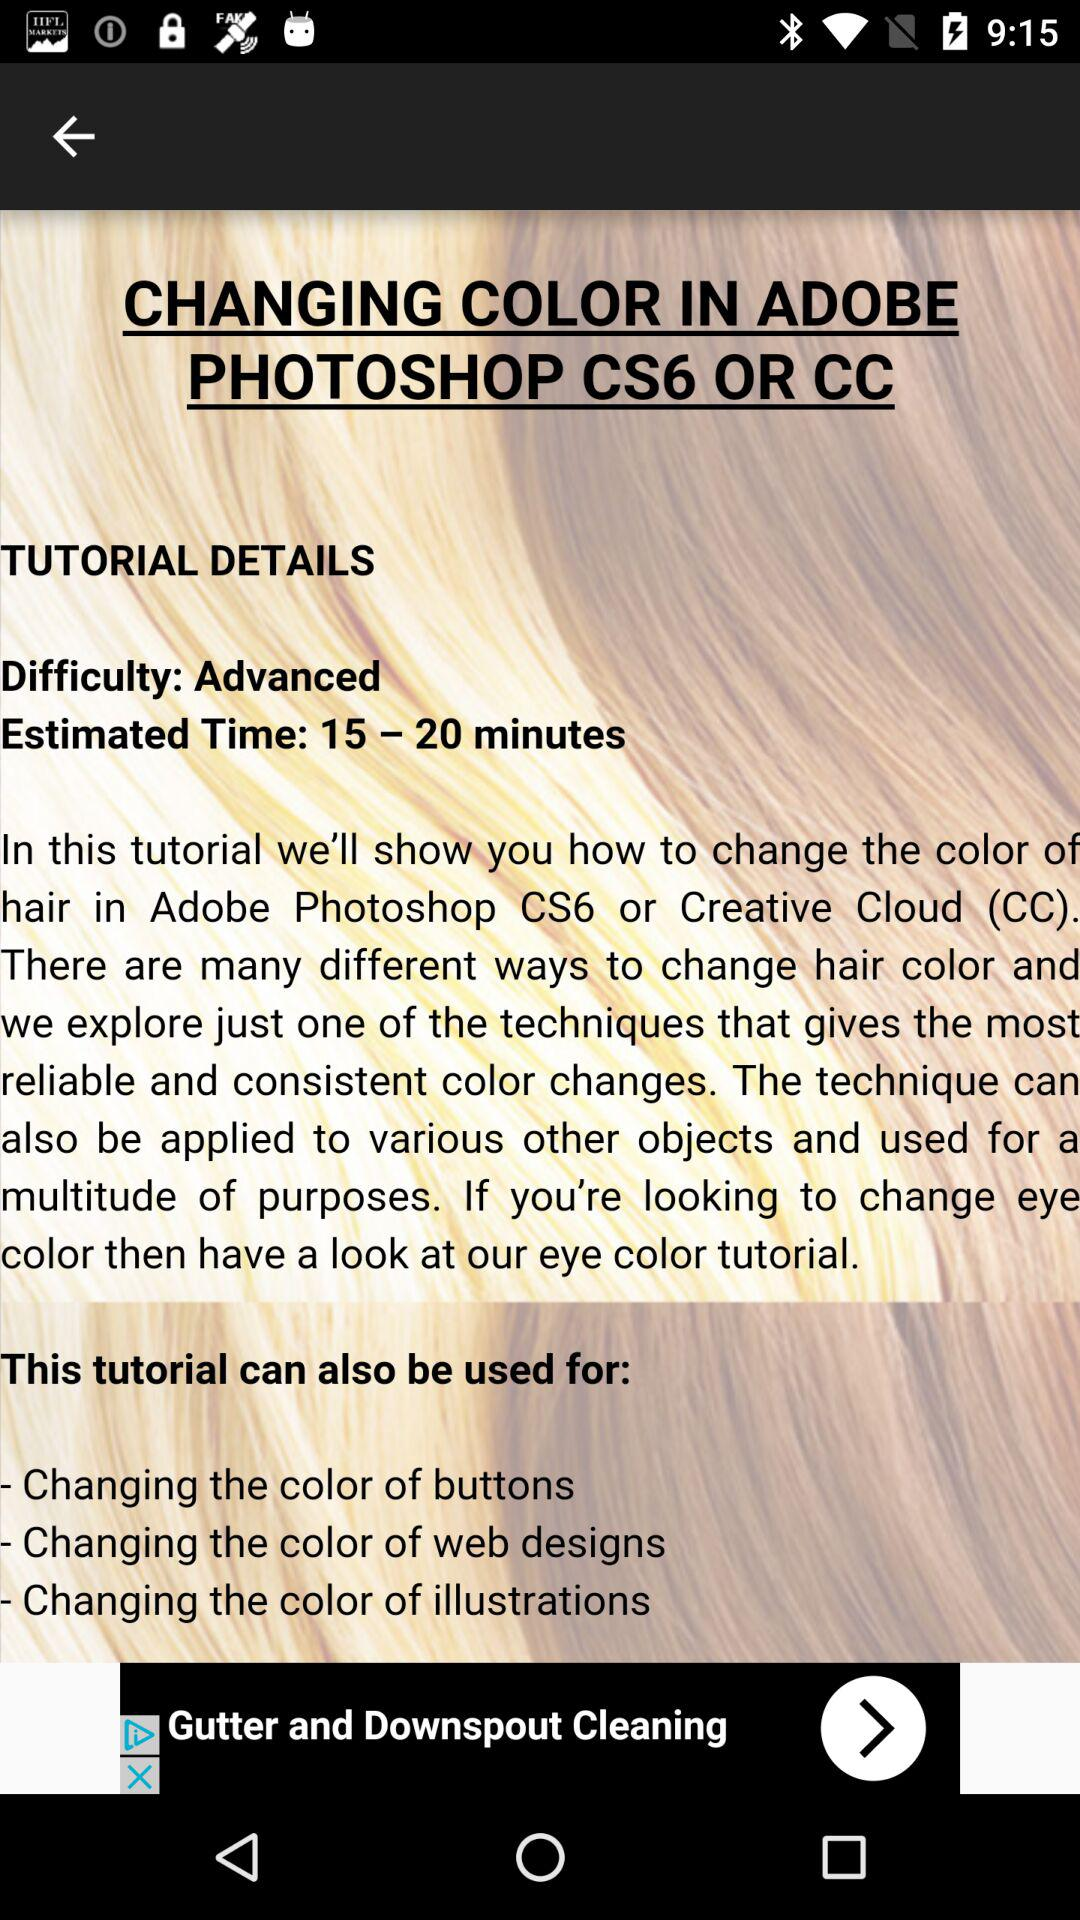What is the difficulty level? The difficulty level is "Advanced". 